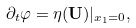<formula> <loc_0><loc_0><loc_500><loc_500>\partial _ { t } \varphi = \eta ( { \mathbf U } ) | _ { x _ { 1 } = 0 } ,</formula> 